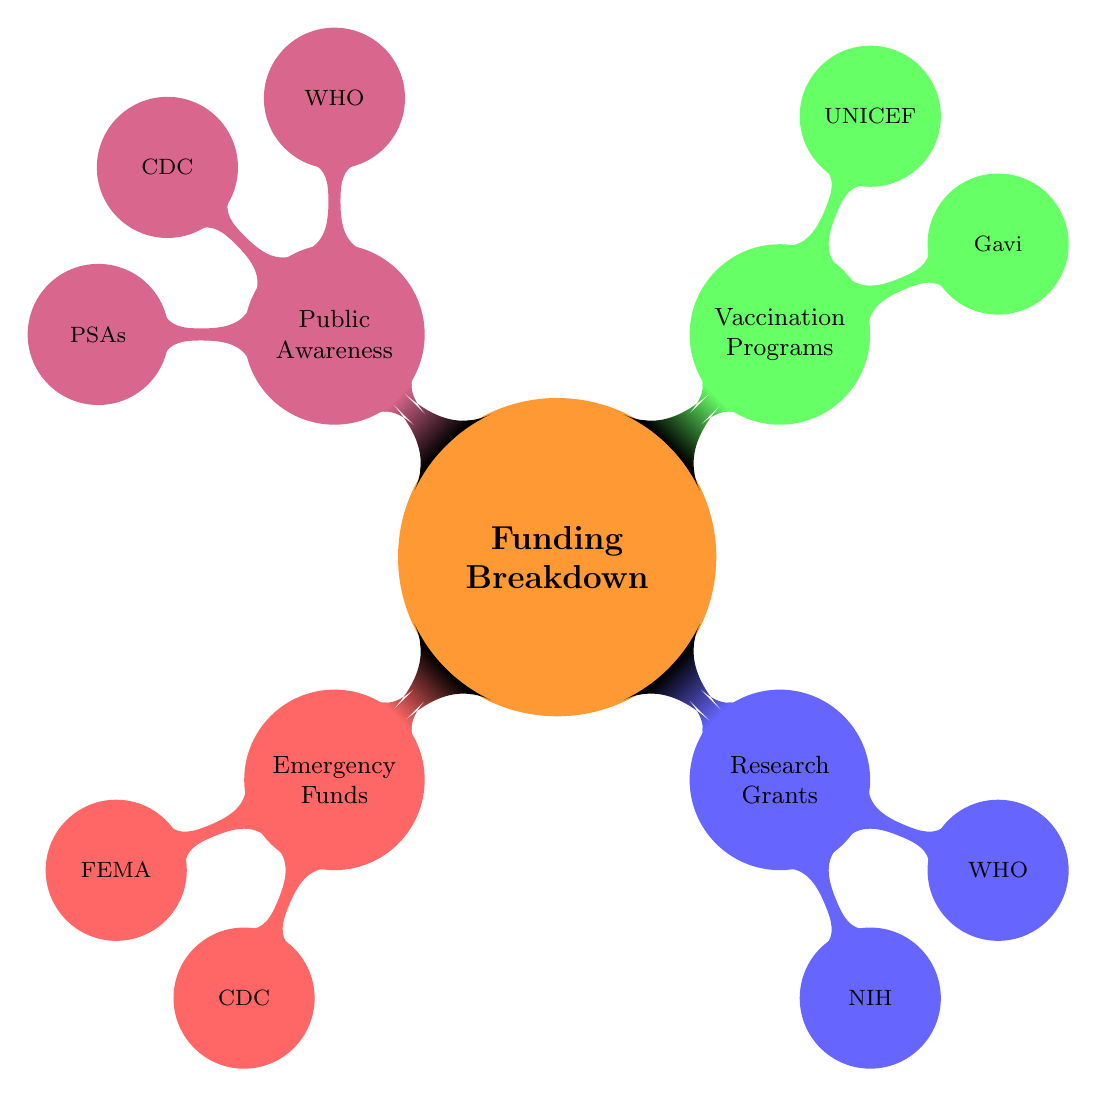What are the two main categories under Emergency Funds? The Emergency Funds category includes two nodes: FEMA and CDC. These are the organizations responsible for emergency funds as shown in the diagram.
Answer: FEMA, CDC How many organizations are listed under Public Awareness Campaigns? Under the Public Awareness Campaigns category, there are three nodes: WHO, CDC, and PSAs. The total count of these nodes is three.
Answer: 3 Which organization is repeated in both Vaccination Programs and Public Awareness Campaigns? The WHO appears in two categories: Vaccination Programs and Public Awareness Campaigns, indicating its multifaceted role in outbreak response initiatives as depicted in the diagram.
Answer: WHO What is the total number of nodes in the diagram? The diagram contains a total of eight nodes: one main node for Funding Breakdown, four categories (Emergency Funds, Research Grants, Vaccination Programs, Public Awareness), and three organizations under Public Awareness. Together, this sums up to eight nodes.
Answer: 8 Which funding category has the fewest organizations listed? Looking at the categories, both Emergency Funds and Research Grants have two organizations listed each (FEMA, CDC for Emergency Funds; NIH, WHO for Research Grants). However, Vaccination Programs has two (Gavi, UNICEF), and Public Awareness has three. Thus, Emergency Funds, Research Grants, and Vaccination Programs tie for the fewest.
Answer: Emergency Funds, Research Grants, Vaccination Programs Which category has the highest number of nodes? The Public Awareness Campaigns category has the most nodes with three organizations (WHO, CDC, PSAs), while all other categories have either two or one, making it the category with the largest number.
Answer: Public Awareness Campaigns 